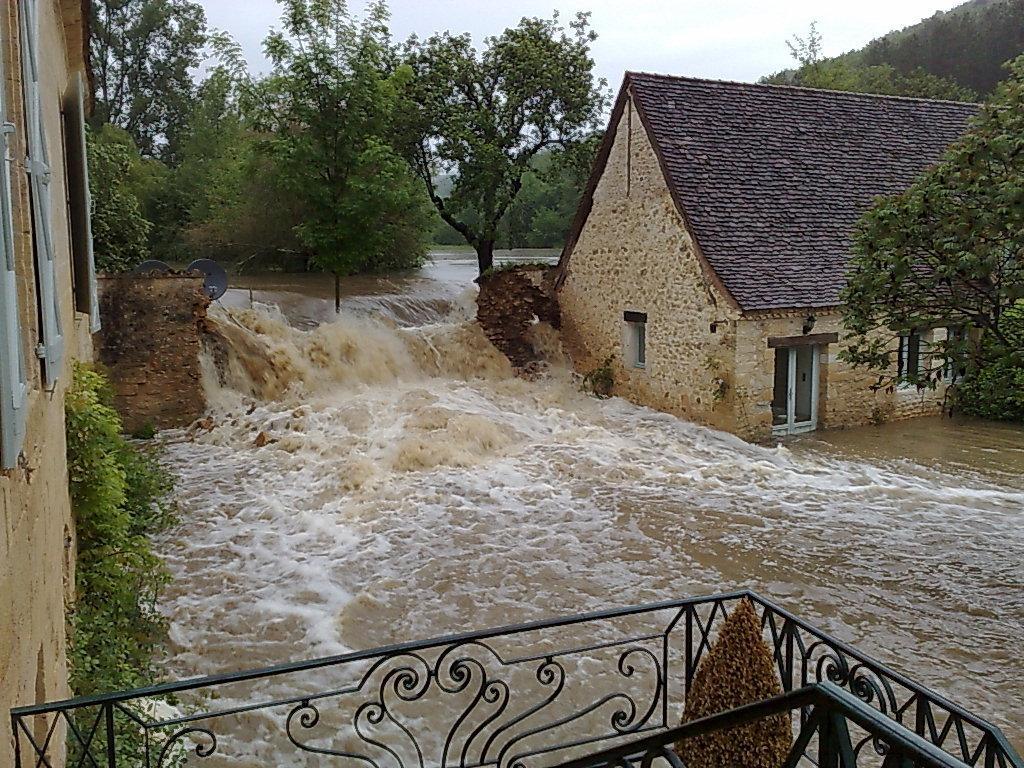Please provide a concise description of this image. In this image, in the middle there are trees, water, waves, buildings, house. At the bottom there are railings, plant. In the background there are hills, sky. 